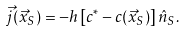Convert formula to latex. <formula><loc_0><loc_0><loc_500><loc_500>\vec { j } ( \vec { x } _ { S } ) = - h \left [ c ^ { \ast } - c ( \vec { x } _ { S } ) \right ] \hat { n } _ { S } .</formula> 